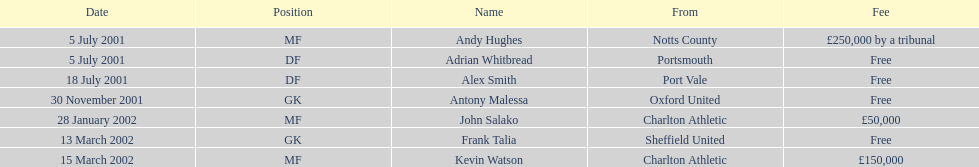Who transferred before 1 august 2001? Andy Hughes, Adrian Whitbread, Alex Smith. 